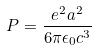<formula> <loc_0><loc_0><loc_500><loc_500>P = \frac { e ^ { 2 } a ^ { 2 } } { 6 \pi \epsilon _ { 0 } c ^ { 3 } }</formula> 